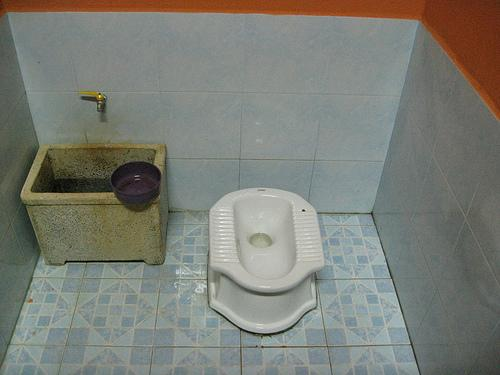Briefly sum up the main objects in the photo. The image features a white toilet, sink with a purple bowl, a silver faucet, and blue tiles on the floor. Express the main idea of the image using a concise statement. An image featuring a small white toilet, a dirty sink, and blue tiles on the restroom floor. Point out the essential objects in the image and any observable pattern. The image highlights a small toilet, dirty sink, faucet, and recurring blue floor tiles. Describe the most crucial elements in the scene using a short sentence. A dirty white sink and a porcelain toilet are present along with a faucet and colorful floor tiles. Briefly describe the core elements of the photograph. A white toilet, a dirt-stained sink, and contrasting blue tiles form the central focus of the image. In one sentence, illustrate the main features of the image. The image displays a white toilet, a grungy sink, and blue floor tiles in a bathroom setting. Quickly detail the primary fixtures in the photo, highlighting any notable aspects. A small toilet, dirty white sink, silver faucet, and blue floor tiles dominate the scene. What are the key components in the image, and how do they relate to one another? The white toilet and sink stand out in the image, connected by a common color theme and nearby faucet. Mention the primary focus of the image and their action, if any. A small ceramic white toilet bowl is visible in the image, with its drain and ridges on the sides. Concisely describe the central theme of the picture. A bathroom scene with a prominent white toilet, a dirty sink, and striking blue floor tiles. 